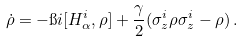Convert formula to latex. <formula><loc_0><loc_0><loc_500><loc_500>\dot { \rho } = - \i i [ H _ { \alpha } ^ { i } , \rho ] + \frac { \gamma } { 2 } ( \sigma _ { z } ^ { i } \rho \sigma _ { z } ^ { i } - \rho ) \, .</formula> 